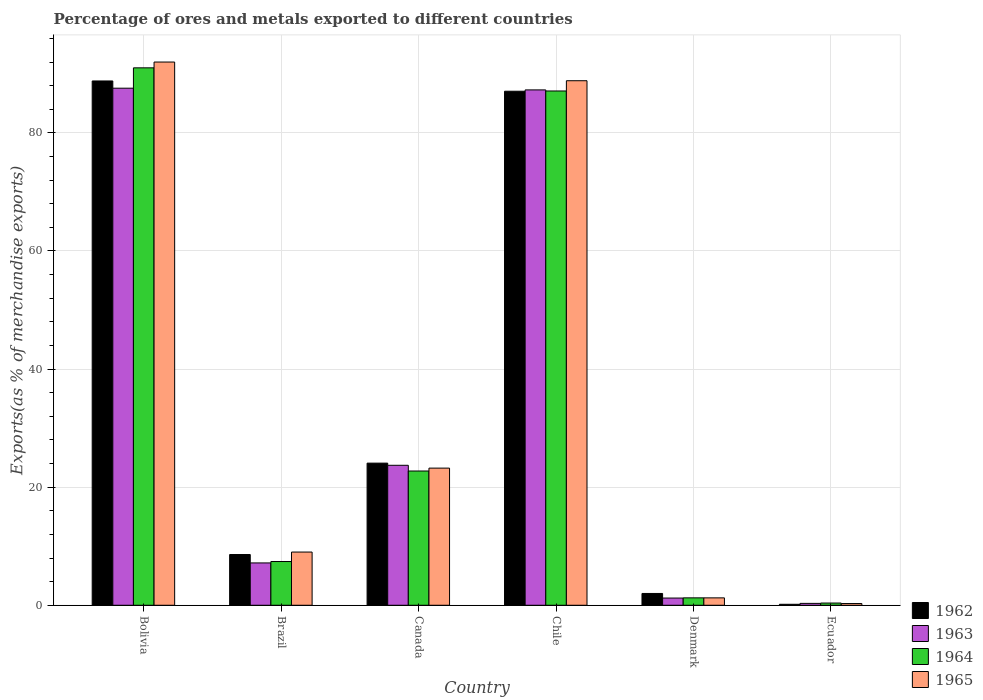How many different coloured bars are there?
Your response must be concise. 4. What is the label of the 5th group of bars from the left?
Keep it short and to the point. Denmark. In how many cases, is the number of bars for a given country not equal to the number of legend labels?
Give a very brief answer. 0. What is the percentage of exports to different countries in 1963 in Brazil?
Ensure brevity in your answer.  7.17. Across all countries, what is the maximum percentage of exports to different countries in 1963?
Your answer should be compact. 87.57. Across all countries, what is the minimum percentage of exports to different countries in 1962?
Your answer should be compact. 0.17. In which country was the percentage of exports to different countries in 1963 minimum?
Offer a very short reply. Ecuador. What is the total percentage of exports to different countries in 1964 in the graph?
Ensure brevity in your answer.  209.89. What is the difference between the percentage of exports to different countries in 1962 in Bolivia and that in Canada?
Your answer should be very brief. 64.72. What is the difference between the percentage of exports to different countries in 1962 in Bolivia and the percentage of exports to different countries in 1964 in Brazil?
Offer a terse response. 81.39. What is the average percentage of exports to different countries in 1964 per country?
Provide a succinct answer. 34.98. What is the difference between the percentage of exports to different countries of/in 1963 and percentage of exports to different countries of/in 1965 in Ecuador?
Your answer should be very brief. 0.03. What is the ratio of the percentage of exports to different countries in 1962 in Brazil to that in Ecuador?
Give a very brief answer. 51.82. What is the difference between the highest and the second highest percentage of exports to different countries in 1963?
Your answer should be compact. -63.58. What is the difference between the highest and the lowest percentage of exports to different countries in 1965?
Your response must be concise. 91.71. In how many countries, is the percentage of exports to different countries in 1963 greater than the average percentage of exports to different countries in 1963 taken over all countries?
Offer a terse response. 2. Is the sum of the percentage of exports to different countries in 1963 in Bolivia and Brazil greater than the maximum percentage of exports to different countries in 1962 across all countries?
Keep it short and to the point. Yes. What does the 4th bar from the left in Canada represents?
Ensure brevity in your answer.  1965. What does the 1st bar from the right in Bolivia represents?
Provide a succinct answer. 1965. Is it the case that in every country, the sum of the percentage of exports to different countries in 1963 and percentage of exports to different countries in 1965 is greater than the percentage of exports to different countries in 1964?
Ensure brevity in your answer.  Yes. How many bars are there?
Your answer should be compact. 24. Are all the bars in the graph horizontal?
Give a very brief answer. No. How many countries are there in the graph?
Make the answer very short. 6. Does the graph contain any zero values?
Ensure brevity in your answer.  No. Does the graph contain grids?
Ensure brevity in your answer.  Yes. How are the legend labels stacked?
Ensure brevity in your answer.  Vertical. What is the title of the graph?
Your answer should be very brief. Percentage of ores and metals exported to different countries. Does "1997" appear as one of the legend labels in the graph?
Your response must be concise. No. What is the label or title of the Y-axis?
Keep it short and to the point. Exports(as % of merchandise exports). What is the Exports(as % of merchandise exports) in 1962 in Bolivia?
Provide a short and direct response. 88.79. What is the Exports(as % of merchandise exports) in 1963 in Bolivia?
Keep it short and to the point. 87.57. What is the Exports(as % of merchandise exports) of 1964 in Bolivia?
Ensure brevity in your answer.  91.02. What is the Exports(as % of merchandise exports) in 1965 in Bolivia?
Give a very brief answer. 92. What is the Exports(as % of merchandise exports) of 1962 in Brazil?
Your answer should be very brief. 8.59. What is the Exports(as % of merchandise exports) of 1963 in Brazil?
Your answer should be compact. 7.17. What is the Exports(as % of merchandise exports) in 1964 in Brazil?
Keep it short and to the point. 7.41. What is the Exports(as % of merchandise exports) in 1965 in Brazil?
Make the answer very short. 9.01. What is the Exports(as % of merchandise exports) in 1962 in Canada?
Your response must be concise. 24.07. What is the Exports(as % of merchandise exports) of 1963 in Canada?
Make the answer very short. 23.71. What is the Exports(as % of merchandise exports) of 1964 in Canada?
Keep it short and to the point. 22.74. What is the Exports(as % of merchandise exports) in 1965 in Canada?
Your answer should be very brief. 23.23. What is the Exports(as % of merchandise exports) of 1962 in Chile?
Your response must be concise. 87.06. What is the Exports(as % of merchandise exports) of 1963 in Chile?
Provide a succinct answer. 87.28. What is the Exports(as % of merchandise exports) in 1964 in Chile?
Your response must be concise. 87.1. What is the Exports(as % of merchandise exports) in 1965 in Chile?
Provide a succinct answer. 88.84. What is the Exports(as % of merchandise exports) of 1962 in Denmark?
Give a very brief answer. 2. What is the Exports(as % of merchandise exports) of 1963 in Denmark?
Your response must be concise. 1.22. What is the Exports(as % of merchandise exports) of 1964 in Denmark?
Keep it short and to the point. 1.25. What is the Exports(as % of merchandise exports) in 1965 in Denmark?
Provide a succinct answer. 1.25. What is the Exports(as % of merchandise exports) of 1962 in Ecuador?
Offer a terse response. 0.17. What is the Exports(as % of merchandise exports) of 1963 in Ecuador?
Make the answer very short. 0.32. What is the Exports(as % of merchandise exports) of 1964 in Ecuador?
Your response must be concise. 0.38. What is the Exports(as % of merchandise exports) in 1965 in Ecuador?
Provide a short and direct response. 0.29. Across all countries, what is the maximum Exports(as % of merchandise exports) in 1962?
Your response must be concise. 88.79. Across all countries, what is the maximum Exports(as % of merchandise exports) in 1963?
Make the answer very short. 87.57. Across all countries, what is the maximum Exports(as % of merchandise exports) of 1964?
Offer a very short reply. 91.02. Across all countries, what is the maximum Exports(as % of merchandise exports) in 1965?
Keep it short and to the point. 92. Across all countries, what is the minimum Exports(as % of merchandise exports) of 1962?
Keep it short and to the point. 0.17. Across all countries, what is the minimum Exports(as % of merchandise exports) of 1963?
Offer a terse response. 0.32. Across all countries, what is the minimum Exports(as % of merchandise exports) in 1964?
Offer a very short reply. 0.38. Across all countries, what is the minimum Exports(as % of merchandise exports) in 1965?
Offer a terse response. 0.29. What is the total Exports(as % of merchandise exports) in 1962 in the graph?
Offer a very short reply. 210.68. What is the total Exports(as % of merchandise exports) of 1963 in the graph?
Offer a very short reply. 207.27. What is the total Exports(as % of merchandise exports) of 1964 in the graph?
Your response must be concise. 209.89. What is the total Exports(as % of merchandise exports) in 1965 in the graph?
Make the answer very short. 214.62. What is the difference between the Exports(as % of merchandise exports) of 1962 in Bolivia and that in Brazil?
Offer a terse response. 80.2. What is the difference between the Exports(as % of merchandise exports) of 1963 in Bolivia and that in Brazil?
Make the answer very short. 80.4. What is the difference between the Exports(as % of merchandise exports) in 1964 in Bolivia and that in Brazil?
Provide a succinct answer. 83.61. What is the difference between the Exports(as % of merchandise exports) of 1965 in Bolivia and that in Brazil?
Keep it short and to the point. 82.99. What is the difference between the Exports(as % of merchandise exports) of 1962 in Bolivia and that in Canada?
Provide a succinct answer. 64.72. What is the difference between the Exports(as % of merchandise exports) in 1963 in Bolivia and that in Canada?
Provide a short and direct response. 63.86. What is the difference between the Exports(as % of merchandise exports) of 1964 in Bolivia and that in Canada?
Your answer should be very brief. 68.28. What is the difference between the Exports(as % of merchandise exports) of 1965 in Bolivia and that in Canada?
Ensure brevity in your answer.  68.77. What is the difference between the Exports(as % of merchandise exports) in 1962 in Bolivia and that in Chile?
Your response must be concise. 1.74. What is the difference between the Exports(as % of merchandise exports) of 1963 in Bolivia and that in Chile?
Offer a very short reply. 0.29. What is the difference between the Exports(as % of merchandise exports) of 1964 in Bolivia and that in Chile?
Provide a short and direct response. 3.92. What is the difference between the Exports(as % of merchandise exports) in 1965 in Bolivia and that in Chile?
Provide a short and direct response. 3.16. What is the difference between the Exports(as % of merchandise exports) of 1962 in Bolivia and that in Denmark?
Your response must be concise. 86.8. What is the difference between the Exports(as % of merchandise exports) of 1963 in Bolivia and that in Denmark?
Your answer should be compact. 86.35. What is the difference between the Exports(as % of merchandise exports) in 1964 in Bolivia and that in Denmark?
Make the answer very short. 89.76. What is the difference between the Exports(as % of merchandise exports) of 1965 in Bolivia and that in Denmark?
Provide a short and direct response. 90.75. What is the difference between the Exports(as % of merchandise exports) of 1962 in Bolivia and that in Ecuador?
Ensure brevity in your answer.  88.63. What is the difference between the Exports(as % of merchandise exports) in 1963 in Bolivia and that in Ecuador?
Your response must be concise. 87.25. What is the difference between the Exports(as % of merchandise exports) in 1964 in Bolivia and that in Ecuador?
Provide a succinct answer. 90.64. What is the difference between the Exports(as % of merchandise exports) in 1965 in Bolivia and that in Ecuador?
Keep it short and to the point. 91.71. What is the difference between the Exports(as % of merchandise exports) of 1962 in Brazil and that in Canada?
Provide a succinct answer. -15.48. What is the difference between the Exports(as % of merchandise exports) in 1963 in Brazil and that in Canada?
Make the answer very short. -16.54. What is the difference between the Exports(as % of merchandise exports) of 1964 in Brazil and that in Canada?
Make the answer very short. -15.33. What is the difference between the Exports(as % of merchandise exports) of 1965 in Brazil and that in Canada?
Keep it short and to the point. -14.22. What is the difference between the Exports(as % of merchandise exports) in 1962 in Brazil and that in Chile?
Your response must be concise. -78.46. What is the difference between the Exports(as % of merchandise exports) in 1963 in Brazil and that in Chile?
Provide a short and direct response. -80.11. What is the difference between the Exports(as % of merchandise exports) in 1964 in Brazil and that in Chile?
Provide a short and direct response. -79.69. What is the difference between the Exports(as % of merchandise exports) in 1965 in Brazil and that in Chile?
Provide a short and direct response. -79.83. What is the difference between the Exports(as % of merchandise exports) of 1962 in Brazil and that in Denmark?
Provide a succinct answer. 6.59. What is the difference between the Exports(as % of merchandise exports) of 1963 in Brazil and that in Denmark?
Keep it short and to the point. 5.95. What is the difference between the Exports(as % of merchandise exports) of 1964 in Brazil and that in Denmark?
Make the answer very short. 6.15. What is the difference between the Exports(as % of merchandise exports) of 1965 in Brazil and that in Denmark?
Provide a succinct answer. 7.76. What is the difference between the Exports(as % of merchandise exports) in 1962 in Brazil and that in Ecuador?
Your response must be concise. 8.43. What is the difference between the Exports(as % of merchandise exports) in 1963 in Brazil and that in Ecuador?
Your answer should be very brief. 6.85. What is the difference between the Exports(as % of merchandise exports) in 1964 in Brazil and that in Ecuador?
Give a very brief answer. 7.03. What is the difference between the Exports(as % of merchandise exports) of 1965 in Brazil and that in Ecuador?
Your answer should be compact. 8.72. What is the difference between the Exports(as % of merchandise exports) in 1962 in Canada and that in Chile?
Provide a succinct answer. -62.98. What is the difference between the Exports(as % of merchandise exports) of 1963 in Canada and that in Chile?
Offer a very short reply. -63.58. What is the difference between the Exports(as % of merchandise exports) in 1964 in Canada and that in Chile?
Provide a succinct answer. -64.36. What is the difference between the Exports(as % of merchandise exports) in 1965 in Canada and that in Chile?
Give a very brief answer. -65.61. What is the difference between the Exports(as % of merchandise exports) of 1962 in Canada and that in Denmark?
Give a very brief answer. 22.07. What is the difference between the Exports(as % of merchandise exports) of 1963 in Canada and that in Denmark?
Keep it short and to the point. 22.49. What is the difference between the Exports(as % of merchandise exports) of 1964 in Canada and that in Denmark?
Offer a terse response. 21.48. What is the difference between the Exports(as % of merchandise exports) in 1965 in Canada and that in Denmark?
Provide a succinct answer. 21.98. What is the difference between the Exports(as % of merchandise exports) of 1962 in Canada and that in Ecuador?
Provide a succinct answer. 23.91. What is the difference between the Exports(as % of merchandise exports) in 1963 in Canada and that in Ecuador?
Your answer should be very brief. 23.39. What is the difference between the Exports(as % of merchandise exports) in 1964 in Canada and that in Ecuador?
Give a very brief answer. 22.36. What is the difference between the Exports(as % of merchandise exports) in 1965 in Canada and that in Ecuador?
Keep it short and to the point. 22.94. What is the difference between the Exports(as % of merchandise exports) in 1962 in Chile and that in Denmark?
Your response must be concise. 85.06. What is the difference between the Exports(as % of merchandise exports) of 1963 in Chile and that in Denmark?
Your answer should be very brief. 86.06. What is the difference between the Exports(as % of merchandise exports) in 1964 in Chile and that in Denmark?
Give a very brief answer. 85.84. What is the difference between the Exports(as % of merchandise exports) in 1965 in Chile and that in Denmark?
Provide a succinct answer. 87.58. What is the difference between the Exports(as % of merchandise exports) of 1962 in Chile and that in Ecuador?
Your response must be concise. 86.89. What is the difference between the Exports(as % of merchandise exports) in 1963 in Chile and that in Ecuador?
Offer a terse response. 86.96. What is the difference between the Exports(as % of merchandise exports) in 1964 in Chile and that in Ecuador?
Ensure brevity in your answer.  86.72. What is the difference between the Exports(as % of merchandise exports) in 1965 in Chile and that in Ecuador?
Offer a terse response. 88.54. What is the difference between the Exports(as % of merchandise exports) of 1962 in Denmark and that in Ecuador?
Offer a terse response. 1.83. What is the difference between the Exports(as % of merchandise exports) in 1963 in Denmark and that in Ecuador?
Your answer should be very brief. 0.9. What is the difference between the Exports(as % of merchandise exports) in 1964 in Denmark and that in Ecuador?
Ensure brevity in your answer.  0.88. What is the difference between the Exports(as % of merchandise exports) in 1965 in Denmark and that in Ecuador?
Make the answer very short. 0.96. What is the difference between the Exports(as % of merchandise exports) in 1962 in Bolivia and the Exports(as % of merchandise exports) in 1963 in Brazil?
Ensure brevity in your answer.  81.62. What is the difference between the Exports(as % of merchandise exports) in 1962 in Bolivia and the Exports(as % of merchandise exports) in 1964 in Brazil?
Give a very brief answer. 81.39. What is the difference between the Exports(as % of merchandise exports) of 1962 in Bolivia and the Exports(as % of merchandise exports) of 1965 in Brazil?
Your response must be concise. 79.78. What is the difference between the Exports(as % of merchandise exports) in 1963 in Bolivia and the Exports(as % of merchandise exports) in 1964 in Brazil?
Offer a very short reply. 80.16. What is the difference between the Exports(as % of merchandise exports) of 1963 in Bolivia and the Exports(as % of merchandise exports) of 1965 in Brazil?
Offer a very short reply. 78.56. What is the difference between the Exports(as % of merchandise exports) of 1964 in Bolivia and the Exports(as % of merchandise exports) of 1965 in Brazil?
Offer a very short reply. 82.01. What is the difference between the Exports(as % of merchandise exports) in 1962 in Bolivia and the Exports(as % of merchandise exports) in 1963 in Canada?
Provide a short and direct response. 65.09. What is the difference between the Exports(as % of merchandise exports) in 1962 in Bolivia and the Exports(as % of merchandise exports) in 1964 in Canada?
Offer a terse response. 66.06. What is the difference between the Exports(as % of merchandise exports) in 1962 in Bolivia and the Exports(as % of merchandise exports) in 1965 in Canada?
Offer a terse response. 65.57. What is the difference between the Exports(as % of merchandise exports) in 1963 in Bolivia and the Exports(as % of merchandise exports) in 1964 in Canada?
Your answer should be compact. 64.83. What is the difference between the Exports(as % of merchandise exports) of 1963 in Bolivia and the Exports(as % of merchandise exports) of 1965 in Canada?
Your response must be concise. 64.34. What is the difference between the Exports(as % of merchandise exports) of 1964 in Bolivia and the Exports(as % of merchandise exports) of 1965 in Canada?
Provide a succinct answer. 67.79. What is the difference between the Exports(as % of merchandise exports) of 1962 in Bolivia and the Exports(as % of merchandise exports) of 1963 in Chile?
Provide a short and direct response. 1.51. What is the difference between the Exports(as % of merchandise exports) in 1962 in Bolivia and the Exports(as % of merchandise exports) in 1964 in Chile?
Your answer should be compact. 1.7. What is the difference between the Exports(as % of merchandise exports) in 1962 in Bolivia and the Exports(as % of merchandise exports) in 1965 in Chile?
Ensure brevity in your answer.  -0.04. What is the difference between the Exports(as % of merchandise exports) in 1963 in Bolivia and the Exports(as % of merchandise exports) in 1964 in Chile?
Your answer should be compact. 0.47. What is the difference between the Exports(as % of merchandise exports) in 1963 in Bolivia and the Exports(as % of merchandise exports) in 1965 in Chile?
Provide a short and direct response. -1.27. What is the difference between the Exports(as % of merchandise exports) of 1964 in Bolivia and the Exports(as % of merchandise exports) of 1965 in Chile?
Offer a terse response. 2.18. What is the difference between the Exports(as % of merchandise exports) in 1962 in Bolivia and the Exports(as % of merchandise exports) in 1963 in Denmark?
Offer a terse response. 87.57. What is the difference between the Exports(as % of merchandise exports) in 1962 in Bolivia and the Exports(as % of merchandise exports) in 1964 in Denmark?
Your answer should be very brief. 87.54. What is the difference between the Exports(as % of merchandise exports) of 1962 in Bolivia and the Exports(as % of merchandise exports) of 1965 in Denmark?
Keep it short and to the point. 87.54. What is the difference between the Exports(as % of merchandise exports) in 1963 in Bolivia and the Exports(as % of merchandise exports) in 1964 in Denmark?
Give a very brief answer. 86.32. What is the difference between the Exports(as % of merchandise exports) in 1963 in Bolivia and the Exports(as % of merchandise exports) in 1965 in Denmark?
Give a very brief answer. 86.32. What is the difference between the Exports(as % of merchandise exports) in 1964 in Bolivia and the Exports(as % of merchandise exports) in 1965 in Denmark?
Make the answer very short. 89.77. What is the difference between the Exports(as % of merchandise exports) in 1962 in Bolivia and the Exports(as % of merchandise exports) in 1963 in Ecuador?
Offer a terse response. 88.47. What is the difference between the Exports(as % of merchandise exports) in 1962 in Bolivia and the Exports(as % of merchandise exports) in 1964 in Ecuador?
Keep it short and to the point. 88.42. What is the difference between the Exports(as % of merchandise exports) in 1962 in Bolivia and the Exports(as % of merchandise exports) in 1965 in Ecuador?
Keep it short and to the point. 88.5. What is the difference between the Exports(as % of merchandise exports) in 1963 in Bolivia and the Exports(as % of merchandise exports) in 1964 in Ecuador?
Your response must be concise. 87.19. What is the difference between the Exports(as % of merchandise exports) of 1963 in Bolivia and the Exports(as % of merchandise exports) of 1965 in Ecuador?
Ensure brevity in your answer.  87.28. What is the difference between the Exports(as % of merchandise exports) of 1964 in Bolivia and the Exports(as % of merchandise exports) of 1965 in Ecuador?
Offer a terse response. 90.73. What is the difference between the Exports(as % of merchandise exports) in 1962 in Brazil and the Exports(as % of merchandise exports) in 1963 in Canada?
Ensure brevity in your answer.  -15.11. What is the difference between the Exports(as % of merchandise exports) of 1962 in Brazil and the Exports(as % of merchandise exports) of 1964 in Canada?
Make the answer very short. -14.15. What is the difference between the Exports(as % of merchandise exports) of 1962 in Brazil and the Exports(as % of merchandise exports) of 1965 in Canada?
Your response must be concise. -14.64. What is the difference between the Exports(as % of merchandise exports) of 1963 in Brazil and the Exports(as % of merchandise exports) of 1964 in Canada?
Keep it short and to the point. -15.57. What is the difference between the Exports(as % of merchandise exports) of 1963 in Brazil and the Exports(as % of merchandise exports) of 1965 in Canada?
Give a very brief answer. -16.06. What is the difference between the Exports(as % of merchandise exports) of 1964 in Brazil and the Exports(as % of merchandise exports) of 1965 in Canada?
Ensure brevity in your answer.  -15.82. What is the difference between the Exports(as % of merchandise exports) in 1962 in Brazil and the Exports(as % of merchandise exports) in 1963 in Chile?
Your response must be concise. -78.69. What is the difference between the Exports(as % of merchandise exports) in 1962 in Brazil and the Exports(as % of merchandise exports) in 1964 in Chile?
Your answer should be compact. -78.51. What is the difference between the Exports(as % of merchandise exports) of 1962 in Brazil and the Exports(as % of merchandise exports) of 1965 in Chile?
Provide a succinct answer. -80.24. What is the difference between the Exports(as % of merchandise exports) in 1963 in Brazil and the Exports(as % of merchandise exports) in 1964 in Chile?
Offer a terse response. -79.93. What is the difference between the Exports(as % of merchandise exports) of 1963 in Brazil and the Exports(as % of merchandise exports) of 1965 in Chile?
Keep it short and to the point. -81.67. What is the difference between the Exports(as % of merchandise exports) in 1964 in Brazil and the Exports(as % of merchandise exports) in 1965 in Chile?
Keep it short and to the point. -81.43. What is the difference between the Exports(as % of merchandise exports) in 1962 in Brazil and the Exports(as % of merchandise exports) in 1963 in Denmark?
Your response must be concise. 7.37. What is the difference between the Exports(as % of merchandise exports) in 1962 in Brazil and the Exports(as % of merchandise exports) in 1964 in Denmark?
Your response must be concise. 7.34. What is the difference between the Exports(as % of merchandise exports) of 1962 in Brazil and the Exports(as % of merchandise exports) of 1965 in Denmark?
Ensure brevity in your answer.  7.34. What is the difference between the Exports(as % of merchandise exports) of 1963 in Brazil and the Exports(as % of merchandise exports) of 1964 in Denmark?
Your answer should be compact. 5.92. What is the difference between the Exports(as % of merchandise exports) in 1963 in Brazil and the Exports(as % of merchandise exports) in 1965 in Denmark?
Your answer should be compact. 5.92. What is the difference between the Exports(as % of merchandise exports) in 1964 in Brazil and the Exports(as % of merchandise exports) in 1965 in Denmark?
Your answer should be compact. 6.16. What is the difference between the Exports(as % of merchandise exports) of 1962 in Brazil and the Exports(as % of merchandise exports) of 1963 in Ecuador?
Your answer should be compact. 8.27. What is the difference between the Exports(as % of merchandise exports) in 1962 in Brazil and the Exports(as % of merchandise exports) in 1964 in Ecuador?
Give a very brief answer. 8.22. What is the difference between the Exports(as % of merchandise exports) in 1962 in Brazil and the Exports(as % of merchandise exports) in 1965 in Ecuador?
Give a very brief answer. 8.3. What is the difference between the Exports(as % of merchandise exports) in 1963 in Brazil and the Exports(as % of merchandise exports) in 1964 in Ecuador?
Keep it short and to the point. 6.79. What is the difference between the Exports(as % of merchandise exports) in 1963 in Brazil and the Exports(as % of merchandise exports) in 1965 in Ecuador?
Ensure brevity in your answer.  6.88. What is the difference between the Exports(as % of merchandise exports) of 1964 in Brazil and the Exports(as % of merchandise exports) of 1965 in Ecuador?
Provide a succinct answer. 7.12. What is the difference between the Exports(as % of merchandise exports) of 1962 in Canada and the Exports(as % of merchandise exports) of 1963 in Chile?
Your answer should be very brief. -63.21. What is the difference between the Exports(as % of merchandise exports) of 1962 in Canada and the Exports(as % of merchandise exports) of 1964 in Chile?
Your answer should be very brief. -63.03. What is the difference between the Exports(as % of merchandise exports) of 1962 in Canada and the Exports(as % of merchandise exports) of 1965 in Chile?
Your response must be concise. -64.76. What is the difference between the Exports(as % of merchandise exports) of 1963 in Canada and the Exports(as % of merchandise exports) of 1964 in Chile?
Your answer should be compact. -63.39. What is the difference between the Exports(as % of merchandise exports) of 1963 in Canada and the Exports(as % of merchandise exports) of 1965 in Chile?
Provide a short and direct response. -65.13. What is the difference between the Exports(as % of merchandise exports) in 1964 in Canada and the Exports(as % of merchandise exports) in 1965 in Chile?
Your answer should be compact. -66.1. What is the difference between the Exports(as % of merchandise exports) of 1962 in Canada and the Exports(as % of merchandise exports) of 1963 in Denmark?
Your answer should be compact. 22.85. What is the difference between the Exports(as % of merchandise exports) of 1962 in Canada and the Exports(as % of merchandise exports) of 1964 in Denmark?
Give a very brief answer. 22.82. What is the difference between the Exports(as % of merchandise exports) in 1962 in Canada and the Exports(as % of merchandise exports) in 1965 in Denmark?
Make the answer very short. 22.82. What is the difference between the Exports(as % of merchandise exports) in 1963 in Canada and the Exports(as % of merchandise exports) in 1964 in Denmark?
Make the answer very short. 22.45. What is the difference between the Exports(as % of merchandise exports) of 1963 in Canada and the Exports(as % of merchandise exports) of 1965 in Denmark?
Offer a terse response. 22.45. What is the difference between the Exports(as % of merchandise exports) in 1964 in Canada and the Exports(as % of merchandise exports) in 1965 in Denmark?
Make the answer very short. 21.49. What is the difference between the Exports(as % of merchandise exports) in 1962 in Canada and the Exports(as % of merchandise exports) in 1963 in Ecuador?
Ensure brevity in your answer.  23.75. What is the difference between the Exports(as % of merchandise exports) in 1962 in Canada and the Exports(as % of merchandise exports) in 1964 in Ecuador?
Provide a succinct answer. 23.7. What is the difference between the Exports(as % of merchandise exports) in 1962 in Canada and the Exports(as % of merchandise exports) in 1965 in Ecuador?
Your response must be concise. 23.78. What is the difference between the Exports(as % of merchandise exports) in 1963 in Canada and the Exports(as % of merchandise exports) in 1964 in Ecuador?
Keep it short and to the point. 23.33. What is the difference between the Exports(as % of merchandise exports) of 1963 in Canada and the Exports(as % of merchandise exports) of 1965 in Ecuador?
Your answer should be compact. 23.41. What is the difference between the Exports(as % of merchandise exports) in 1964 in Canada and the Exports(as % of merchandise exports) in 1965 in Ecuador?
Offer a terse response. 22.45. What is the difference between the Exports(as % of merchandise exports) of 1962 in Chile and the Exports(as % of merchandise exports) of 1963 in Denmark?
Make the answer very short. 85.84. What is the difference between the Exports(as % of merchandise exports) in 1962 in Chile and the Exports(as % of merchandise exports) in 1964 in Denmark?
Your response must be concise. 85.8. What is the difference between the Exports(as % of merchandise exports) of 1962 in Chile and the Exports(as % of merchandise exports) of 1965 in Denmark?
Make the answer very short. 85.8. What is the difference between the Exports(as % of merchandise exports) in 1963 in Chile and the Exports(as % of merchandise exports) in 1964 in Denmark?
Give a very brief answer. 86.03. What is the difference between the Exports(as % of merchandise exports) of 1963 in Chile and the Exports(as % of merchandise exports) of 1965 in Denmark?
Make the answer very short. 86.03. What is the difference between the Exports(as % of merchandise exports) in 1964 in Chile and the Exports(as % of merchandise exports) in 1965 in Denmark?
Ensure brevity in your answer.  85.85. What is the difference between the Exports(as % of merchandise exports) in 1962 in Chile and the Exports(as % of merchandise exports) in 1963 in Ecuador?
Your answer should be very brief. 86.74. What is the difference between the Exports(as % of merchandise exports) in 1962 in Chile and the Exports(as % of merchandise exports) in 1964 in Ecuador?
Your answer should be compact. 86.68. What is the difference between the Exports(as % of merchandise exports) of 1962 in Chile and the Exports(as % of merchandise exports) of 1965 in Ecuador?
Offer a terse response. 86.76. What is the difference between the Exports(as % of merchandise exports) of 1963 in Chile and the Exports(as % of merchandise exports) of 1964 in Ecuador?
Provide a succinct answer. 86.91. What is the difference between the Exports(as % of merchandise exports) of 1963 in Chile and the Exports(as % of merchandise exports) of 1965 in Ecuador?
Provide a short and direct response. 86.99. What is the difference between the Exports(as % of merchandise exports) of 1964 in Chile and the Exports(as % of merchandise exports) of 1965 in Ecuador?
Your response must be concise. 86.81. What is the difference between the Exports(as % of merchandise exports) in 1962 in Denmark and the Exports(as % of merchandise exports) in 1963 in Ecuador?
Your answer should be very brief. 1.68. What is the difference between the Exports(as % of merchandise exports) in 1962 in Denmark and the Exports(as % of merchandise exports) in 1964 in Ecuador?
Make the answer very short. 1.62. What is the difference between the Exports(as % of merchandise exports) of 1962 in Denmark and the Exports(as % of merchandise exports) of 1965 in Ecuador?
Your answer should be compact. 1.71. What is the difference between the Exports(as % of merchandise exports) of 1963 in Denmark and the Exports(as % of merchandise exports) of 1964 in Ecuador?
Provide a succinct answer. 0.84. What is the difference between the Exports(as % of merchandise exports) of 1963 in Denmark and the Exports(as % of merchandise exports) of 1965 in Ecuador?
Provide a short and direct response. 0.93. What is the difference between the Exports(as % of merchandise exports) of 1964 in Denmark and the Exports(as % of merchandise exports) of 1965 in Ecuador?
Your answer should be very brief. 0.96. What is the average Exports(as % of merchandise exports) of 1962 per country?
Provide a succinct answer. 35.11. What is the average Exports(as % of merchandise exports) of 1963 per country?
Keep it short and to the point. 34.54. What is the average Exports(as % of merchandise exports) in 1964 per country?
Give a very brief answer. 34.98. What is the average Exports(as % of merchandise exports) in 1965 per country?
Provide a short and direct response. 35.77. What is the difference between the Exports(as % of merchandise exports) in 1962 and Exports(as % of merchandise exports) in 1963 in Bolivia?
Your response must be concise. 1.22. What is the difference between the Exports(as % of merchandise exports) of 1962 and Exports(as % of merchandise exports) of 1964 in Bolivia?
Offer a very short reply. -2.22. What is the difference between the Exports(as % of merchandise exports) of 1962 and Exports(as % of merchandise exports) of 1965 in Bolivia?
Make the answer very short. -3.21. What is the difference between the Exports(as % of merchandise exports) of 1963 and Exports(as % of merchandise exports) of 1964 in Bolivia?
Your answer should be very brief. -3.45. What is the difference between the Exports(as % of merchandise exports) of 1963 and Exports(as % of merchandise exports) of 1965 in Bolivia?
Provide a short and direct response. -4.43. What is the difference between the Exports(as % of merchandise exports) in 1964 and Exports(as % of merchandise exports) in 1965 in Bolivia?
Your answer should be compact. -0.98. What is the difference between the Exports(as % of merchandise exports) of 1962 and Exports(as % of merchandise exports) of 1963 in Brazil?
Provide a succinct answer. 1.42. What is the difference between the Exports(as % of merchandise exports) of 1962 and Exports(as % of merchandise exports) of 1964 in Brazil?
Your response must be concise. 1.18. What is the difference between the Exports(as % of merchandise exports) in 1962 and Exports(as % of merchandise exports) in 1965 in Brazil?
Offer a very short reply. -0.42. What is the difference between the Exports(as % of merchandise exports) in 1963 and Exports(as % of merchandise exports) in 1964 in Brazil?
Provide a succinct answer. -0.24. What is the difference between the Exports(as % of merchandise exports) of 1963 and Exports(as % of merchandise exports) of 1965 in Brazil?
Provide a succinct answer. -1.84. What is the difference between the Exports(as % of merchandise exports) of 1964 and Exports(as % of merchandise exports) of 1965 in Brazil?
Give a very brief answer. -1.6. What is the difference between the Exports(as % of merchandise exports) of 1962 and Exports(as % of merchandise exports) of 1963 in Canada?
Provide a succinct answer. 0.37. What is the difference between the Exports(as % of merchandise exports) of 1962 and Exports(as % of merchandise exports) of 1964 in Canada?
Offer a very short reply. 1.33. What is the difference between the Exports(as % of merchandise exports) in 1962 and Exports(as % of merchandise exports) in 1965 in Canada?
Offer a very short reply. 0.84. What is the difference between the Exports(as % of merchandise exports) of 1963 and Exports(as % of merchandise exports) of 1964 in Canada?
Give a very brief answer. 0.97. What is the difference between the Exports(as % of merchandise exports) in 1963 and Exports(as % of merchandise exports) in 1965 in Canada?
Ensure brevity in your answer.  0.48. What is the difference between the Exports(as % of merchandise exports) of 1964 and Exports(as % of merchandise exports) of 1965 in Canada?
Your answer should be compact. -0.49. What is the difference between the Exports(as % of merchandise exports) of 1962 and Exports(as % of merchandise exports) of 1963 in Chile?
Your answer should be compact. -0.23. What is the difference between the Exports(as % of merchandise exports) of 1962 and Exports(as % of merchandise exports) of 1964 in Chile?
Your answer should be very brief. -0.04. What is the difference between the Exports(as % of merchandise exports) of 1962 and Exports(as % of merchandise exports) of 1965 in Chile?
Give a very brief answer. -1.78. What is the difference between the Exports(as % of merchandise exports) in 1963 and Exports(as % of merchandise exports) in 1964 in Chile?
Your response must be concise. 0.18. What is the difference between the Exports(as % of merchandise exports) of 1963 and Exports(as % of merchandise exports) of 1965 in Chile?
Make the answer very short. -1.55. What is the difference between the Exports(as % of merchandise exports) in 1964 and Exports(as % of merchandise exports) in 1965 in Chile?
Offer a terse response. -1.74. What is the difference between the Exports(as % of merchandise exports) in 1962 and Exports(as % of merchandise exports) in 1963 in Denmark?
Your answer should be compact. 0.78. What is the difference between the Exports(as % of merchandise exports) of 1962 and Exports(as % of merchandise exports) of 1964 in Denmark?
Make the answer very short. 0.74. What is the difference between the Exports(as % of merchandise exports) in 1962 and Exports(as % of merchandise exports) in 1965 in Denmark?
Make the answer very short. 0.75. What is the difference between the Exports(as % of merchandise exports) in 1963 and Exports(as % of merchandise exports) in 1964 in Denmark?
Provide a short and direct response. -0.03. What is the difference between the Exports(as % of merchandise exports) in 1963 and Exports(as % of merchandise exports) in 1965 in Denmark?
Your answer should be compact. -0.03. What is the difference between the Exports(as % of merchandise exports) in 1964 and Exports(as % of merchandise exports) in 1965 in Denmark?
Offer a terse response. 0. What is the difference between the Exports(as % of merchandise exports) in 1962 and Exports(as % of merchandise exports) in 1963 in Ecuador?
Offer a terse response. -0.15. What is the difference between the Exports(as % of merchandise exports) in 1962 and Exports(as % of merchandise exports) in 1964 in Ecuador?
Provide a succinct answer. -0.21. What is the difference between the Exports(as % of merchandise exports) in 1962 and Exports(as % of merchandise exports) in 1965 in Ecuador?
Your response must be concise. -0.13. What is the difference between the Exports(as % of merchandise exports) of 1963 and Exports(as % of merchandise exports) of 1964 in Ecuador?
Offer a terse response. -0.06. What is the difference between the Exports(as % of merchandise exports) of 1963 and Exports(as % of merchandise exports) of 1965 in Ecuador?
Offer a terse response. 0.03. What is the difference between the Exports(as % of merchandise exports) in 1964 and Exports(as % of merchandise exports) in 1965 in Ecuador?
Offer a very short reply. 0.08. What is the ratio of the Exports(as % of merchandise exports) of 1962 in Bolivia to that in Brazil?
Provide a succinct answer. 10.33. What is the ratio of the Exports(as % of merchandise exports) of 1963 in Bolivia to that in Brazil?
Give a very brief answer. 12.21. What is the ratio of the Exports(as % of merchandise exports) in 1964 in Bolivia to that in Brazil?
Your answer should be compact. 12.29. What is the ratio of the Exports(as % of merchandise exports) in 1965 in Bolivia to that in Brazil?
Provide a succinct answer. 10.21. What is the ratio of the Exports(as % of merchandise exports) in 1962 in Bolivia to that in Canada?
Keep it short and to the point. 3.69. What is the ratio of the Exports(as % of merchandise exports) of 1963 in Bolivia to that in Canada?
Your answer should be compact. 3.69. What is the ratio of the Exports(as % of merchandise exports) of 1964 in Bolivia to that in Canada?
Offer a very short reply. 4. What is the ratio of the Exports(as % of merchandise exports) in 1965 in Bolivia to that in Canada?
Your response must be concise. 3.96. What is the ratio of the Exports(as % of merchandise exports) in 1964 in Bolivia to that in Chile?
Your response must be concise. 1.04. What is the ratio of the Exports(as % of merchandise exports) of 1965 in Bolivia to that in Chile?
Offer a very short reply. 1.04. What is the ratio of the Exports(as % of merchandise exports) of 1962 in Bolivia to that in Denmark?
Offer a very short reply. 44.45. What is the ratio of the Exports(as % of merchandise exports) in 1963 in Bolivia to that in Denmark?
Your response must be concise. 71.8. What is the ratio of the Exports(as % of merchandise exports) of 1964 in Bolivia to that in Denmark?
Keep it short and to the point. 72.57. What is the ratio of the Exports(as % of merchandise exports) in 1965 in Bolivia to that in Denmark?
Ensure brevity in your answer.  73.53. What is the ratio of the Exports(as % of merchandise exports) in 1962 in Bolivia to that in Ecuador?
Offer a very short reply. 535.54. What is the ratio of the Exports(as % of merchandise exports) of 1963 in Bolivia to that in Ecuador?
Offer a terse response. 274.33. What is the ratio of the Exports(as % of merchandise exports) in 1964 in Bolivia to that in Ecuador?
Offer a terse response. 242.27. What is the ratio of the Exports(as % of merchandise exports) in 1965 in Bolivia to that in Ecuador?
Offer a very short reply. 315.34. What is the ratio of the Exports(as % of merchandise exports) in 1962 in Brazil to that in Canada?
Keep it short and to the point. 0.36. What is the ratio of the Exports(as % of merchandise exports) in 1963 in Brazil to that in Canada?
Provide a succinct answer. 0.3. What is the ratio of the Exports(as % of merchandise exports) of 1964 in Brazil to that in Canada?
Keep it short and to the point. 0.33. What is the ratio of the Exports(as % of merchandise exports) of 1965 in Brazil to that in Canada?
Provide a succinct answer. 0.39. What is the ratio of the Exports(as % of merchandise exports) of 1962 in Brazil to that in Chile?
Your answer should be very brief. 0.1. What is the ratio of the Exports(as % of merchandise exports) of 1963 in Brazil to that in Chile?
Offer a very short reply. 0.08. What is the ratio of the Exports(as % of merchandise exports) of 1964 in Brazil to that in Chile?
Keep it short and to the point. 0.09. What is the ratio of the Exports(as % of merchandise exports) of 1965 in Brazil to that in Chile?
Your answer should be compact. 0.1. What is the ratio of the Exports(as % of merchandise exports) of 1962 in Brazil to that in Denmark?
Provide a short and direct response. 4.3. What is the ratio of the Exports(as % of merchandise exports) in 1963 in Brazil to that in Denmark?
Your response must be concise. 5.88. What is the ratio of the Exports(as % of merchandise exports) of 1964 in Brazil to that in Denmark?
Your answer should be very brief. 5.91. What is the ratio of the Exports(as % of merchandise exports) of 1965 in Brazil to that in Denmark?
Keep it short and to the point. 7.2. What is the ratio of the Exports(as % of merchandise exports) of 1962 in Brazil to that in Ecuador?
Offer a terse response. 51.82. What is the ratio of the Exports(as % of merchandise exports) in 1963 in Brazil to that in Ecuador?
Your response must be concise. 22.46. What is the ratio of the Exports(as % of merchandise exports) of 1964 in Brazil to that in Ecuador?
Provide a succinct answer. 19.72. What is the ratio of the Exports(as % of merchandise exports) in 1965 in Brazil to that in Ecuador?
Give a very brief answer. 30.88. What is the ratio of the Exports(as % of merchandise exports) in 1962 in Canada to that in Chile?
Offer a very short reply. 0.28. What is the ratio of the Exports(as % of merchandise exports) of 1963 in Canada to that in Chile?
Your answer should be compact. 0.27. What is the ratio of the Exports(as % of merchandise exports) in 1964 in Canada to that in Chile?
Ensure brevity in your answer.  0.26. What is the ratio of the Exports(as % of merchandise exports) of 1965 in Canada to that in Chile?
Provide a succinct answer. 0.26. What is the ratio of the Exports(as % of merchandise exports) in 1962 in Canada to that in Denmark?
Ensure brevity in your answer.  12.05. What is the ratio of the Exports(as % of merchandise exports) of 1963 in Canada to that in Denmark?
Ensure brevity in your answer.  19.44. What is the ratio of the Exports(as % of merchandise exports) in 1964 in Canada to that in Denmark?
Keep it short and to the point. 18.13. What is the ratio of the Exports(as % of merchandise exports) in 1965 in Canada to that in Denmark?
Your answer should be very brief. 18.56. What is the ratio of the Exports(as % of merchandise exports) in 1962 in Canada to that in Ecuador?
Your answer should be compact. 145.18. What is the ratio of the Exports(as % of merchandise exports) of 1963 in Canada to that in Ecuador?
Make the answer very short. 74.26. What is the ratio of the Exports(as % of merchandise exports) of 1964 in Canada to that in Ecuador?
Ensure brevity in your answer.  60.52. What is the ratio of the Exports(as % of merchandise exports) of 1965 in Canada to that in Ecuador?
Provide a succinct answer. 79.61. What is the ratio of the Exports(as % of merchandise exports) of 1962 in Chile to that in Denmark?
Provide a short and direct response. 43.58. What is the ratio of the Exports(as % of merchandise exports) of 1963 in Chile to that in Denmark?
Offer a very short reply. 71.57. What is the ratio of the Exports(as % of merchandise exports) of 1964 in Chile to that in Denmark?
Give a very brief answer. 69.44. What is the ratio of the Exports(as % of merchandise exports) in 1965 in Chile to that in Denmark?
Your answer should be compact. 71. What is the ratio of the Exports(as % of merchandise exports) in 1962 in Chile to that in Ecuador?
Give a very brief answer. 525.05. What is the ratio of the Exports(as % of merchandise exports) of 1963 in Chile to that in Ecuador?
Ensure brevity in your answer.  273.43. What is the ratio of the Exports(as % of merchandise exports) of 1964 in Chile to that in Ecuador?
Make the answer very short. 231.84. What is the ratio of the Exports(as % of merchandise exports) in 1965 in Chile to that in Ecuador?
Keep it short and to the point. 304.49. What is the ratio of the Exports(as % of merchandise exports) of 1962 in Denmark to that in Ecuador?
Offer a terse response. 12.05. What is the ratio of the Exports(as % of merchandise exports) of 1963 in Denmark to that in Ecuador?
Your answer should be compact. 3.82. What is the ratio of the Exports(as % of merchandise exports) in 1964 in Denmark to that in Ecuador?
Make the answer very short. 3.34. What is the ratio of the Exports(as % of merchandise exports) in 1965 in Denmark to that in Ecuador?
Offer a terse response. 4.29. What is the difference between the highest and the second highest Exports(as % of merchandise exports) of 1962?
Keep it short and to the point. 1.74. What is the difference between the highest and the second highest Exports(as % of merchandise exports) of 1963?
Provide a succinct answer. 0.29. What is the difference between the highest and the second highest Exports(as % of merchandise exports) in 1964?
Provide a short and direct response. 3.92. What is the difference between the highest and the second highest Exports(as % of merchandise exports) in 1965?
Provide a short and direct response. 3.16. What is the difference between the highest and the lowest Exports(as % of merchandise exports) of 1962?
Make the answer very short. 88.63. What is the difference between the highest and the lowest Exports(as % of merchandise exports) in 1963?
Provide a succinct answer. 87.25. What is the difference between the highest and the lowest Exports(as % of merchandise exports) of 1964?
Ensure brevity in your answer.  90.64. What is the difference between the highest and the lowest Exports(as % of merchandise exports) of 1965?
Your answer should be very brief. 91.71. 